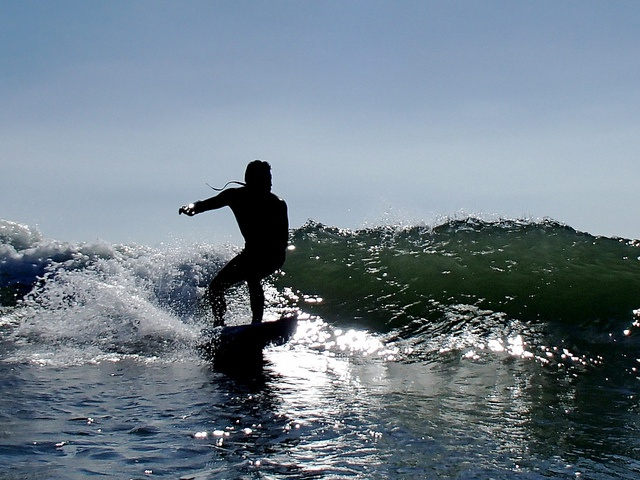Describe the objects in this image and their specific colors. I can see people in gray, black, and darkgray tones and surfboard in gray, black, and darkgray tones in this image. 